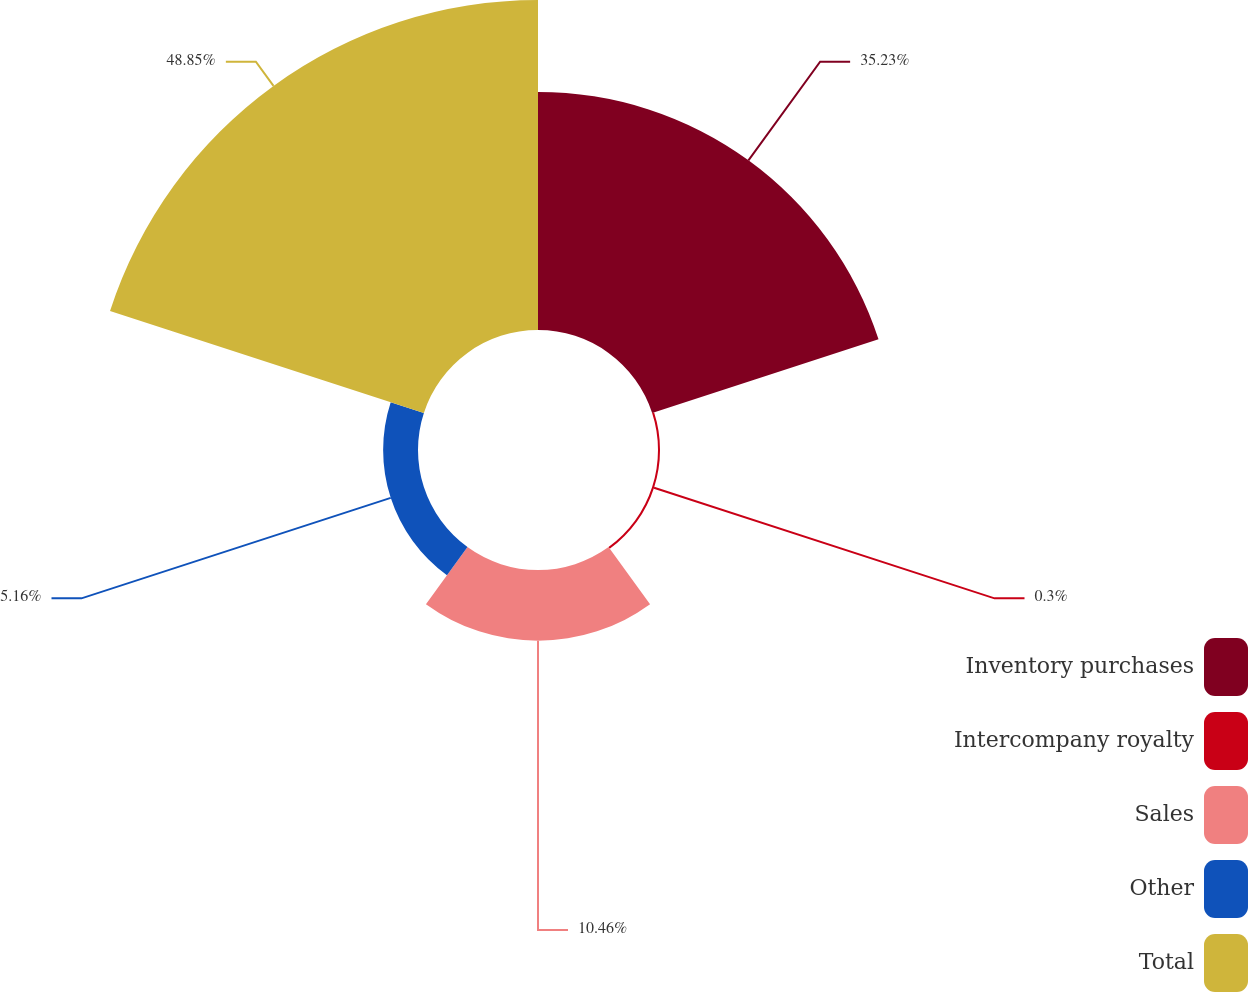Convert chart to OTSL. <chart><loc_0><loc_0><loc_500><loc_500><pie_chart><fcel>Inventory purchases<fcel>Intercompany royalty<fcel>Sales<fcel>Other<fcel>Total<nl><fcel>35.23%<fcel>0.3%<fcel>10.46%<fcel>5.16%<fcel>48.84%<nl></chart> 